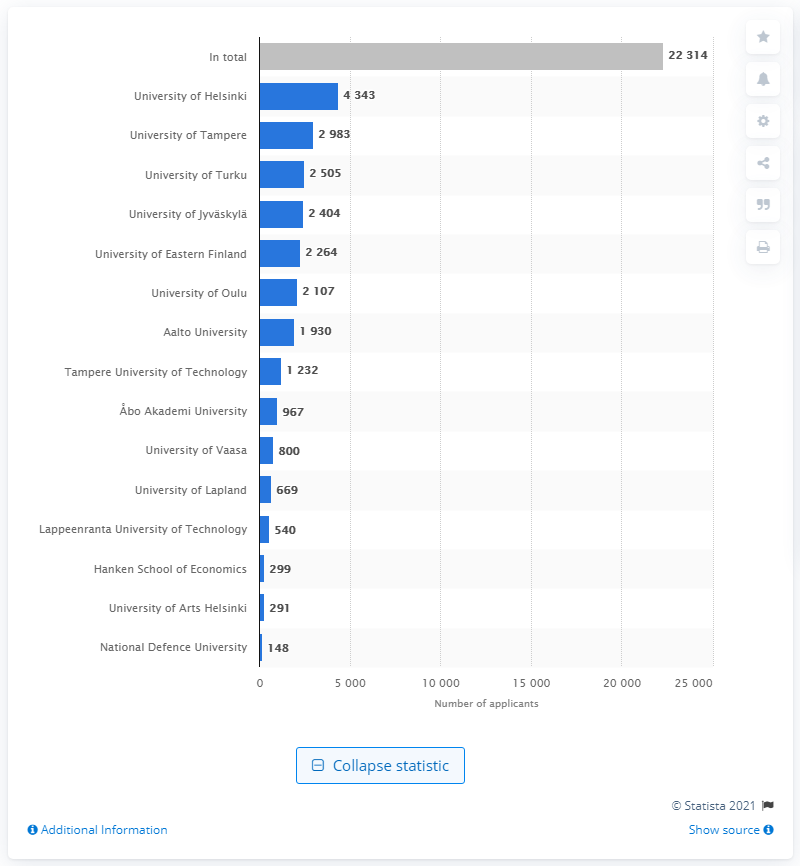Identify some key points in this picture. In 2019, a total of 22314 individuals accepted and received study placements in Finland. 